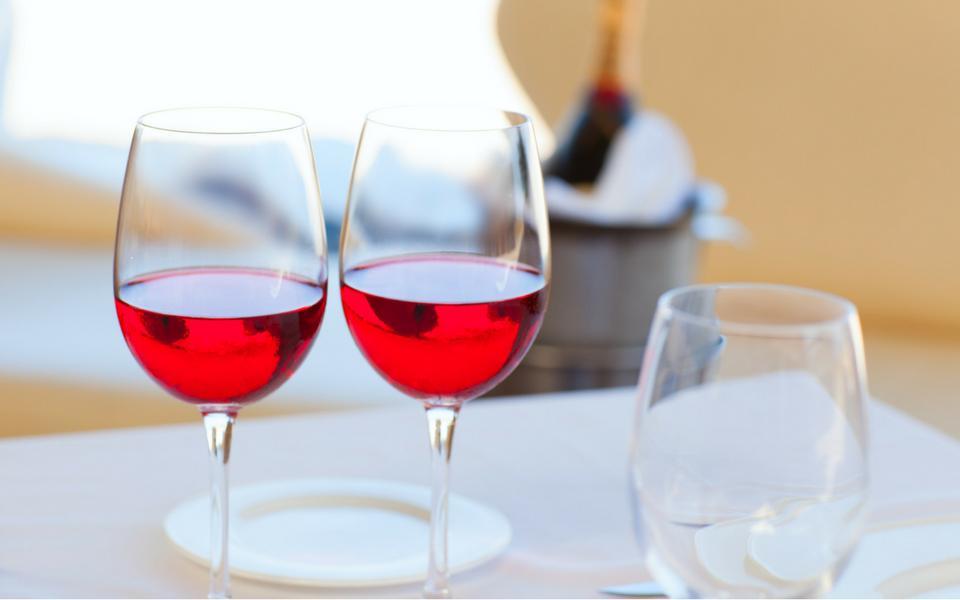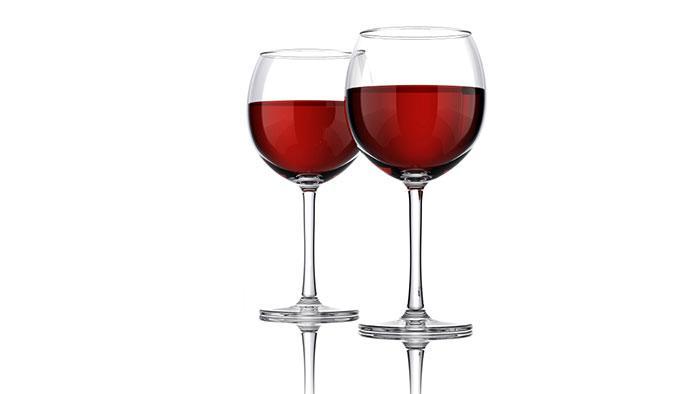The first image is the image on the left, the second image is the image on the right. Examine the images to the left and right. Is the description "A bottle of wine is near at least one wine glass in one of the images." accurate? Answer yes or no. No. The first image is the image on the left, the second image is the image on the right. Assess this claim about the two images: "An image depicts red wine splashing in a stemmed glass.". Correct or not? Answer yes or no. No. 